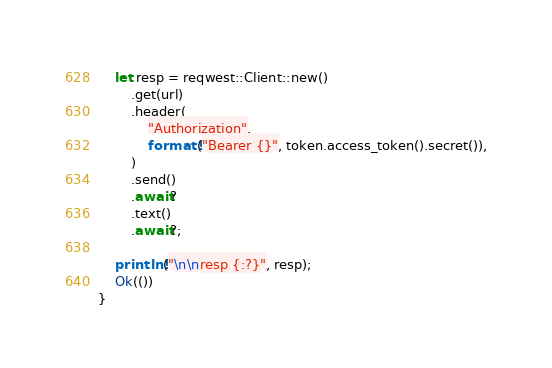<code> <loc_0><loc_0><loc_500><loc_500><_Rust_>    let resp = reqwest::Client::new()
        .get(url)
        .header(
            "Authorization",
            format!("Bearer {}", token.access_token().secret()),
        )
        .send()
        .await?
        .text()
        .await?;

    println!("\n\nresp {:?}", resp);
    Ok(())
}
</code> 